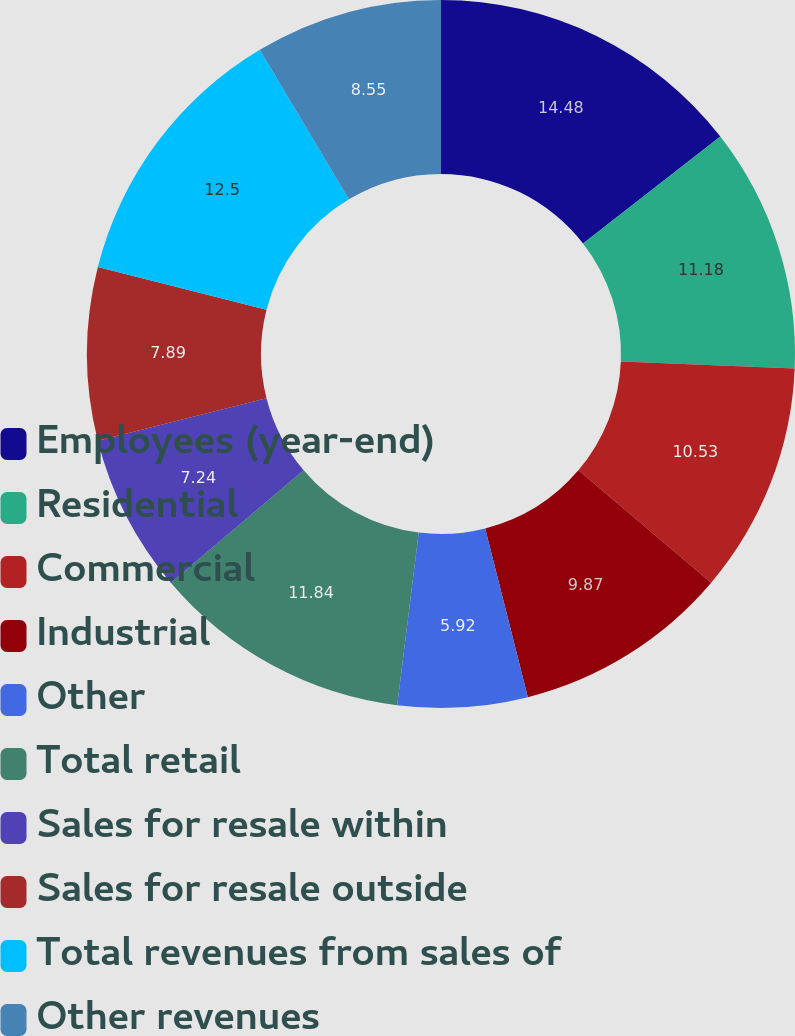<chart> <loc_0><loc_0><loc_500><loc_500><pie_chart><fcel>Employees (year-end)<fcel>Residential<fcel>Commercial<fcel>Industrial<fcel>Other<fcel>Total retail<fcel>Sales for resale within<fcel>Sales for resale outside<fcel>Total revenues from sales of<fcel>Other revenues<nl><fcel>14.47%<fcel>11.18%<fcel>10.53%<fcel>9.87%<fcel>5.92%<fcel>11.84%<fcel>7.24%<fcel>7.89%<fcel>12.5%<fcel>8.55%<nl></chart> 